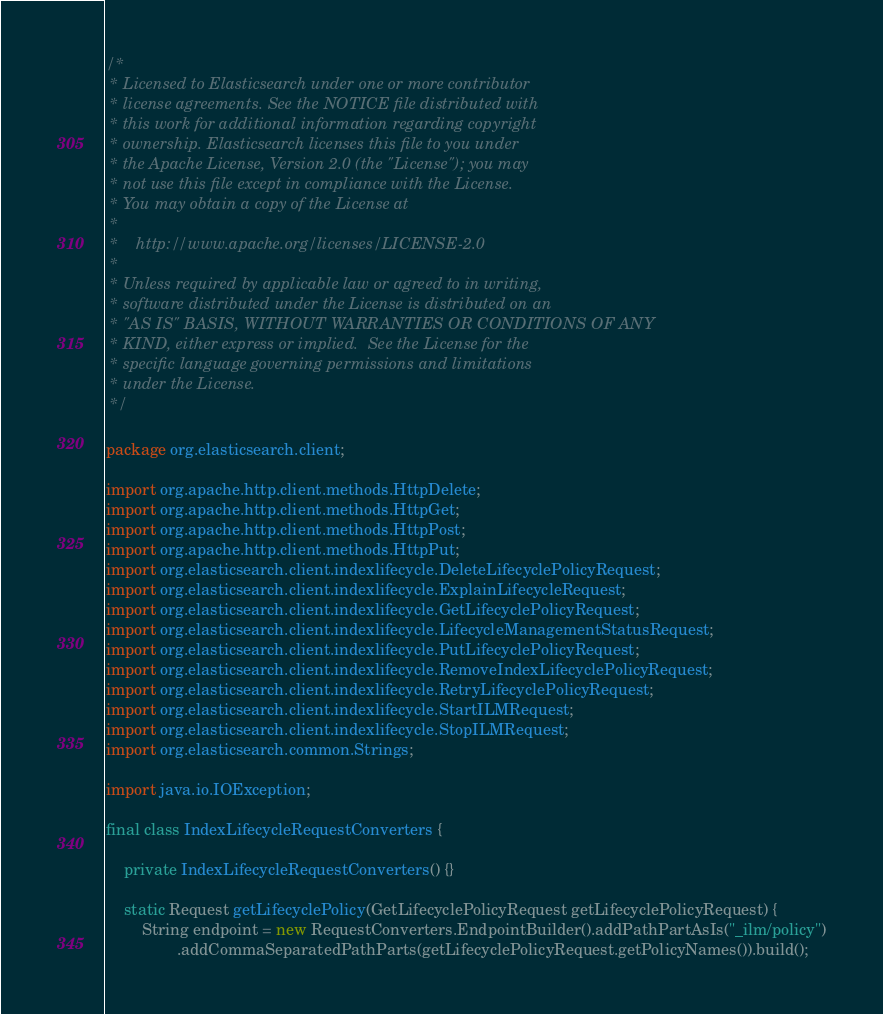<code> <loc_0><loc_0><loc_500><loc_500><_Java_>/*
 * Licensed to Elasticsearch under one or more contributor
 * license agreements. See the NOTICE file distributed with
 * this work for additional information regarding copyright
 * ownership. Elasticsearch licenses this file to you under
 * the Apache License, Version 2.0 (the "License"); you may
 * not use this file except in compliance with the License.
 * You may obtain a copy of the License at
 *
 *    http://www.apache.org/licenses/LICENSE-2.0
 *
 * Unless required by applicable law or agreed to in writing,
 * software distributed under the License is distributed on an
 * "AS IS" BASIS, WITHOUT WARRANTIES OR CONDITIONS OF ANY
 * KIND, either express or implied.  See the License for the
 * specific language governing permissions and limitations
 * under the License.
 */

package org.elasticsearch.client;

import org.apache.http.client.methods.HttpDelete;
import org.apache.http.client.methods.HttpGet;
import org.apache.http.client.methods.HttpPost;
import org.apache.http.client.methods.HttpPut;
import org.elasticsearch.client.indexlifecycle.DeleteLifecyclePolicyRequest;
import org.elasticsearch.client.indexlifecycle.ExplainLifecycleRequest;
import org.elasticsearch.client.indexlifecycle.GetLifecyclePolicyRequest;
import org.elasticsearch.client.indexlifecycle.LifecycleManagementStatusRequest;
import org.elasticsearch.client.indexlifecycle.PutLifecyclePolicyRequest;
import org.elasticsearch.client.indexlifecycle.RemoveIndexLifecyclePolicyRequest;
import org.elasticsearch.client.indexlifecycle.RetryLifecyclePolicyRequest;
import org.elasticsearch.client.indexlifecycle.StartILMRequest;
import org.elasticsearch.client.indexlifecycle.StopILMRequest;
import org.elasticsearch.common.Strings;

import java.io.IOException;

final class IndexLifecycleRequestConverters {

    private IndexLifecycleRequestConverters() {}

    static Request getLifecyclePolicy(GetLifecyclePolicyRequest getLifecyclePolicyRequest) {
        String endpoint = new RequestConverters.EndpointBuilder().addPathPartAsIs("_ilm/policy")
                .addCommaSeparatedPathParts(getLifecyclePolicyRequest.getPolicyNames()).build();</code> 